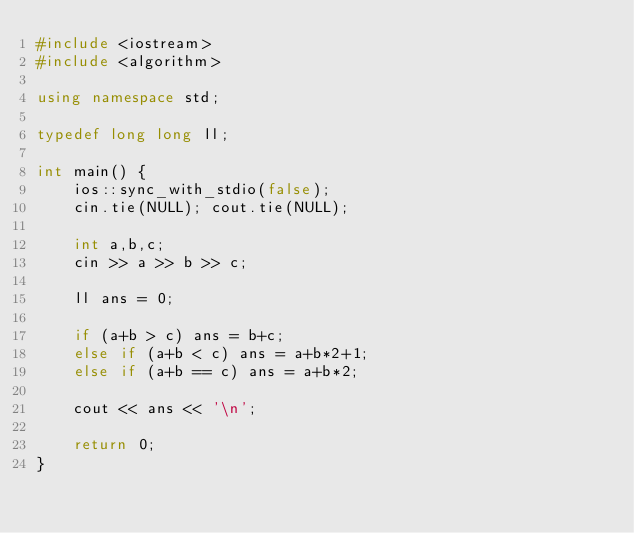Convert code to text. <code><loc_0><loc_0><loc_500><loc_500><_C++_>#include <iostream>
#include <algorithm>

using namespace std;

typedef long long ll;

int main() {
    ios::sync_with_stdio(false);
    cin.tie(NULL); cout.tie(NULL);
    
    int a,b,c;
    cin >> a >> b >> c;
    
    ll ans = 0;
    
    if (a+b > c) ans = b+c;
    else if (a+b < c) ans = a+b*2+1;
    else if (a+b == c) ans = a+b*2;
    
    cout << ans << '\n';
    
    return 0;
}
</code> 